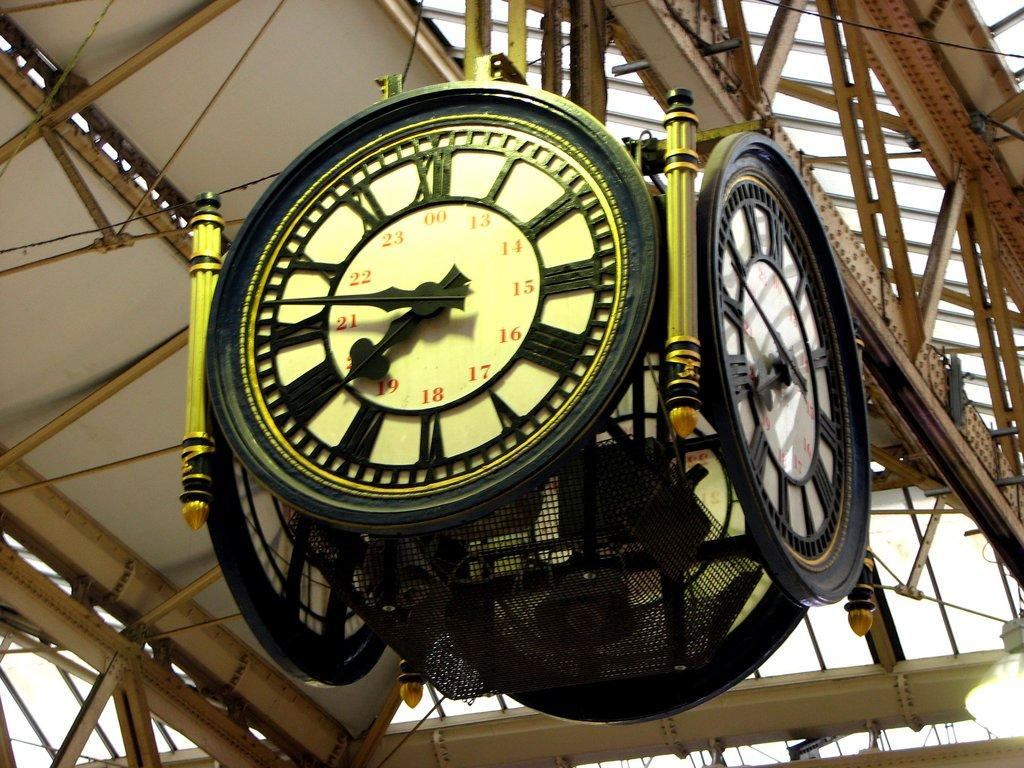<image>
Create a compact narrative representing the image presented. A large, square clock that has a face on all four sides, shows a time of 6:46. 